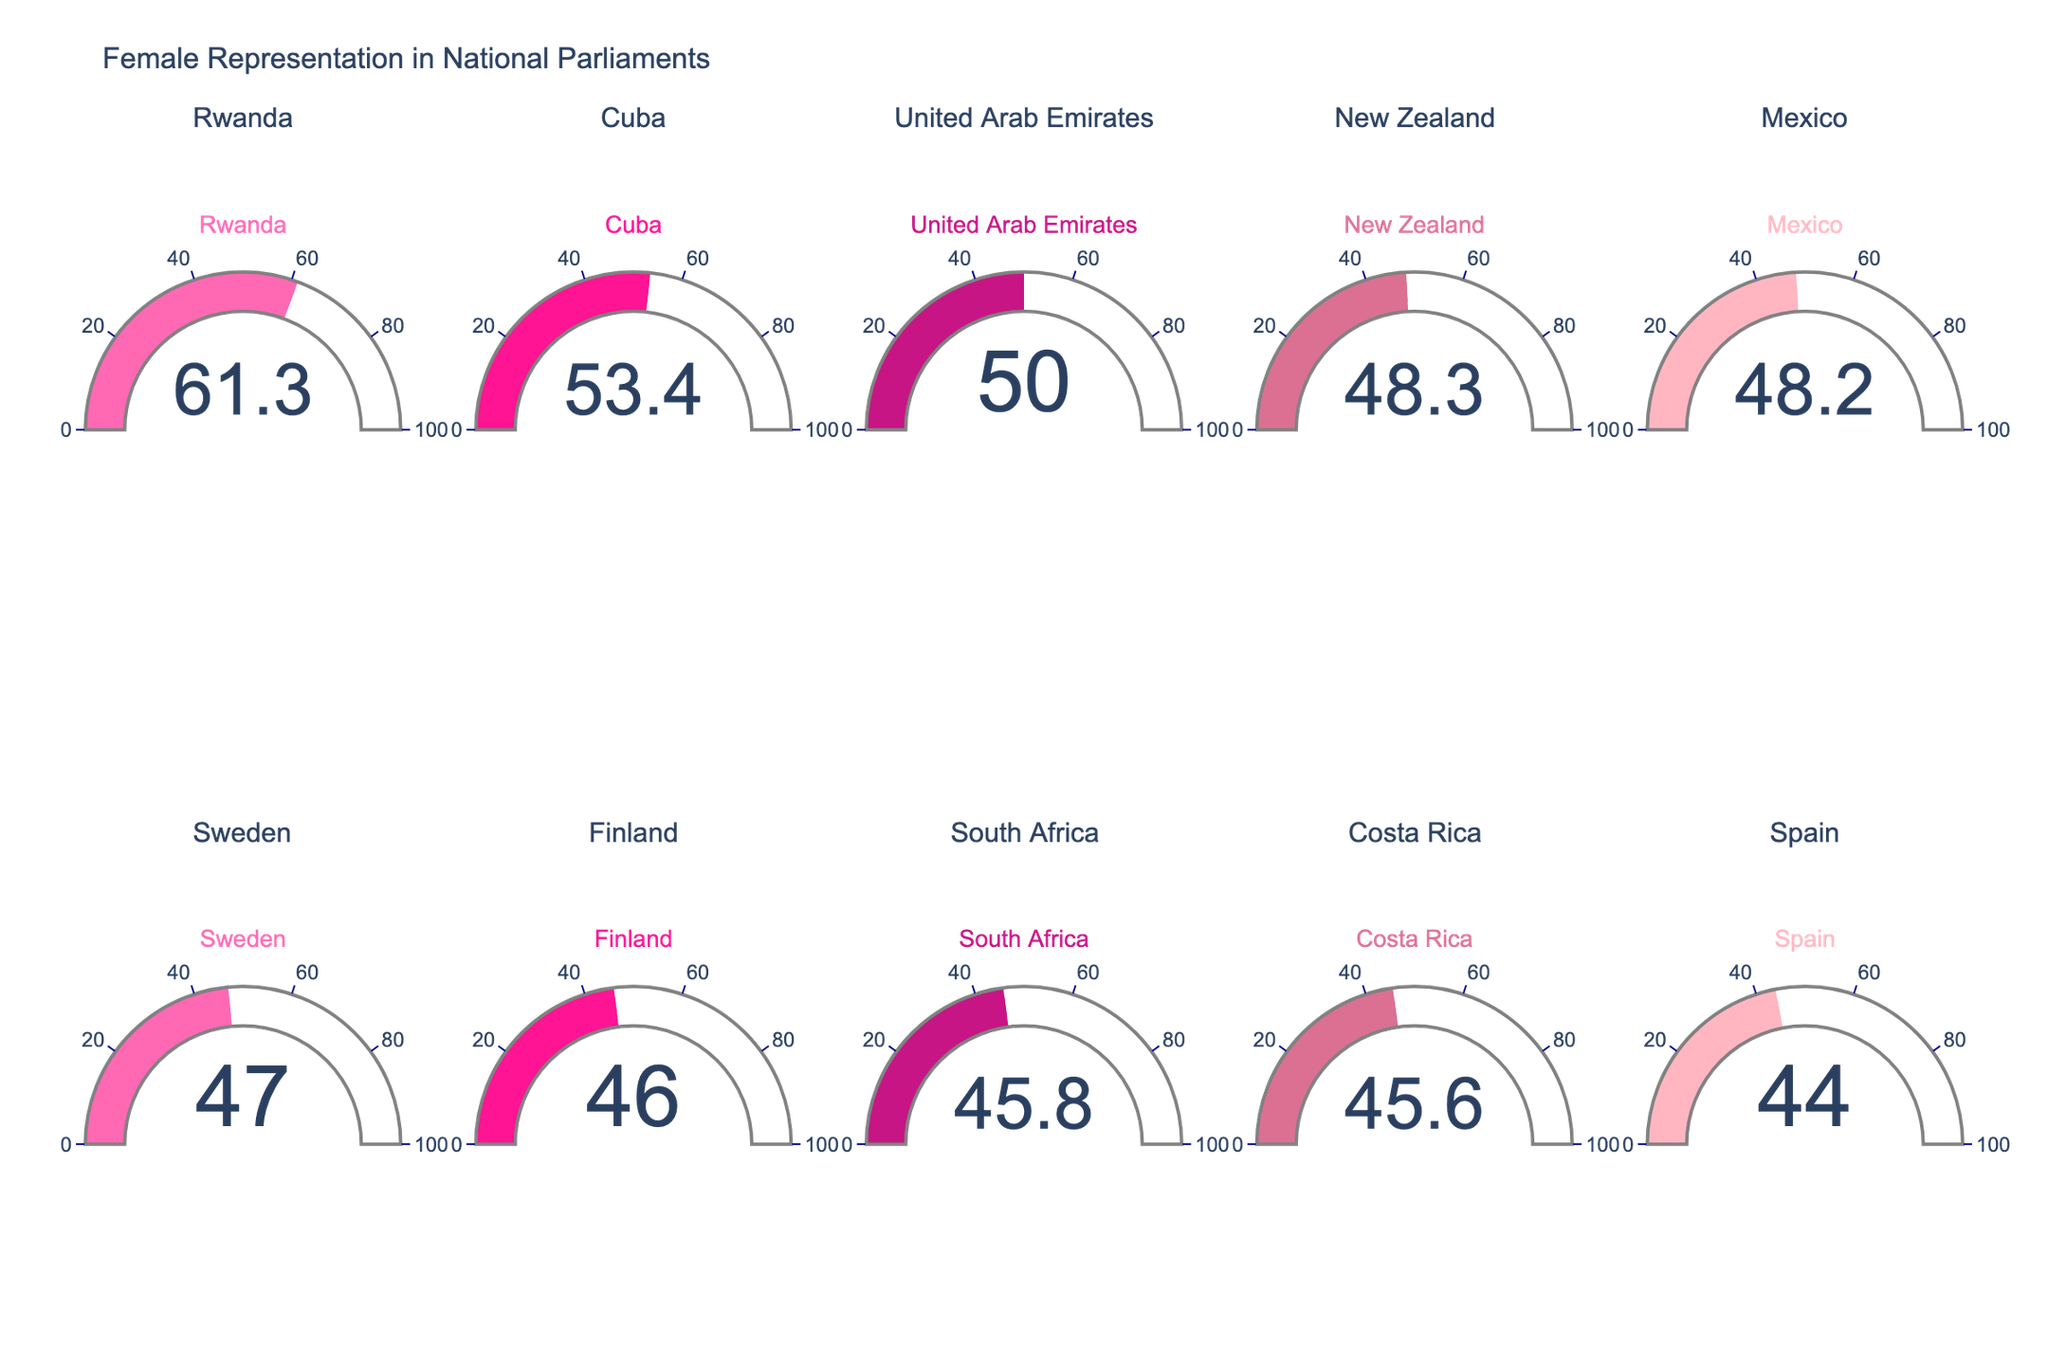What is the title of the figure? The title of the figure can be observed at the top of the plot. The title states the main subject of the plot.
Answer: Female Representation in National Parliaments How many countries are represented in the plot? The plot includes each country in a separate gauge. By counting the gauges or looking at the subplot titles, you can determine the number of countries.
Answer: 10 Which country has the highest percentage of female representation? The gauge displaying the highest value represents the country with the highest percentage of female representation. In this case, it is Rwanda with 61.3%.
Answer: Rwanda What is the average percentage of female representation across all these countries? To find the average, sum all the percentages and divide by the number of countries. The sum is 61.3 + 53.4 + 50.0 + 48.3 + 48.2 + 47.0 + 46.0 + 45.8 + 45.6 + 44.0 = 489.6. Divide this sum by 10 as there are 10 countries.
Answer: 48.96 Which country has a female representation percentage closest to the plot's average? Calculate the average as done previously (48.96). Then, find the country with the percentage closest to this average by checking each gauge value.
Answer: Costa Rica (45.6%) What’s the range of female representation percentages among these countries? To find the range, subtract the lowest percentage from the highest percentage. The highest is 61.3% (Rwanda), and the lowest is 44.0% (Spain). Thus, the range is 61.3 - 44.0.
Answer: 17.3 How many countries have female representation above 50%? Examine each gauge and count the number of countries with a percentage higher than 50%.
Answer: 3 Which countries have a lower percentage of female representation than Spain? Identify Spain's percentage (44.0%) and see if any other country falls below this threshold. Since no other country has a percentage lower than 44.0%, none are identified.
Answer: None Compare the female representation in New Zealand and Mexico. Which one is higher? Check the gauges for New Zealand (48.3%) and Mexico (48.2%) and compare the values.
Answer: New Zealand Is the gauge layout symmetrical in terms of the number of gauges per row and column? The figure shows that it has 5 columns and 2 rows of gauges (5 * 2), making it symmetrical in terms of layout.
Answer: Yes 